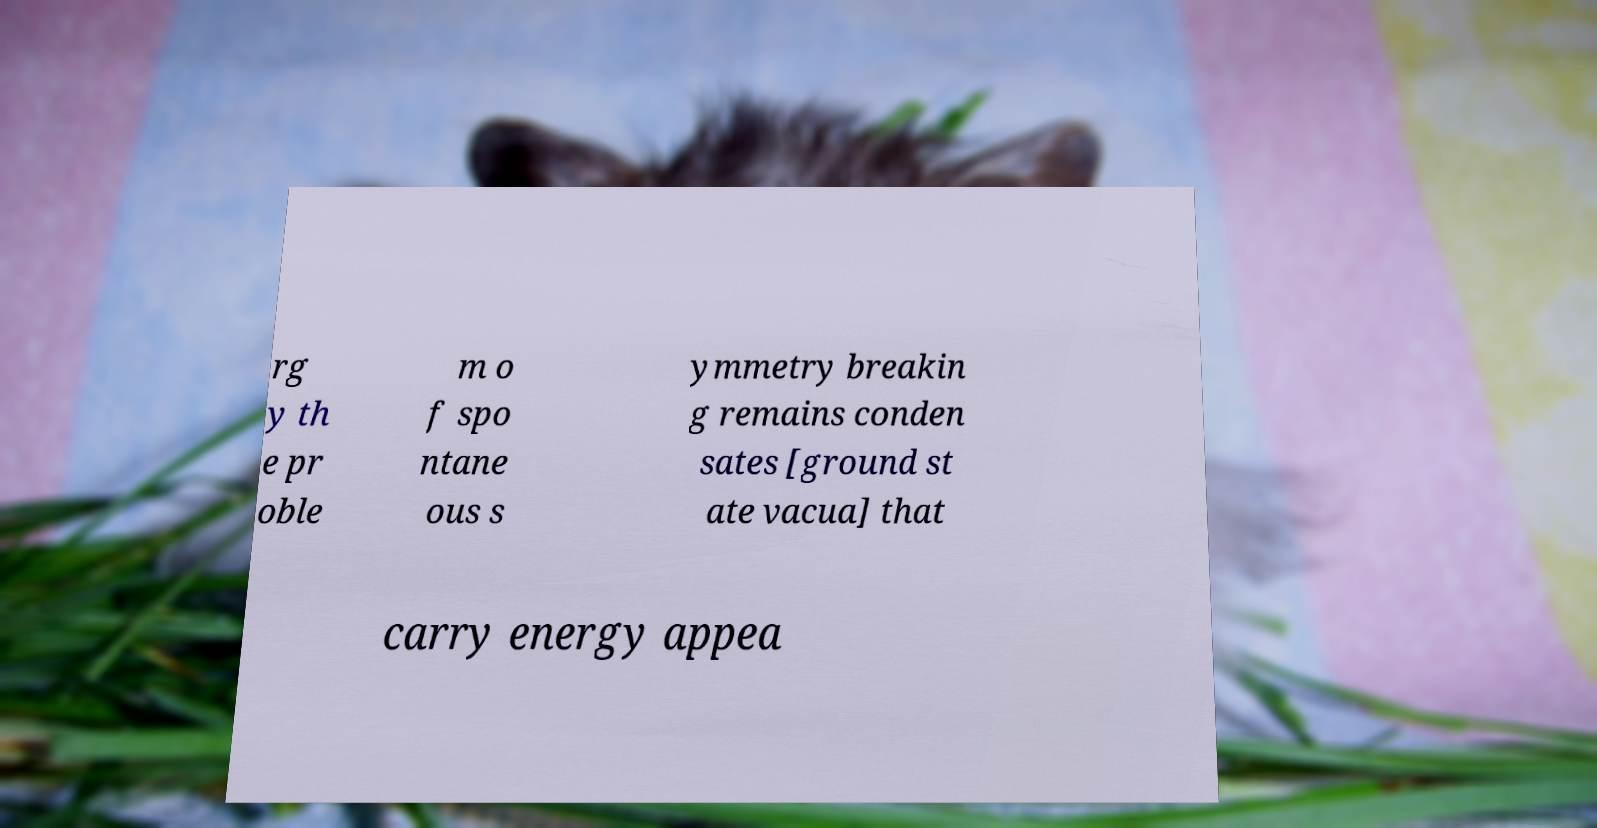Can you read and provide the text displayed in the image?This photo seems to have some interesting text. Can you extract and type it out for me? rg y th e pr oble m o f spo ntane ous s ymmetry breakin g remains conden sates [ground st ate vacua] that carry energy appea 